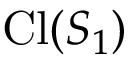<formula> <loc_0><loc_0><loc_500><loc_500>C l ( S _ { 1 } )</formula> 